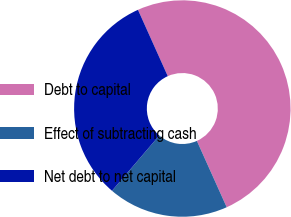Convert chart to OTSL. <chart><loc_0><loc_0><loc_500><loc_500><pie_chart><fcel>Debt to capital<fcel>Effect of subtracting cash<fcel>Net debt to net capital<nl><fcel>50.0%<fcel>17.98%<fcel>32.02%<nl></chart> 